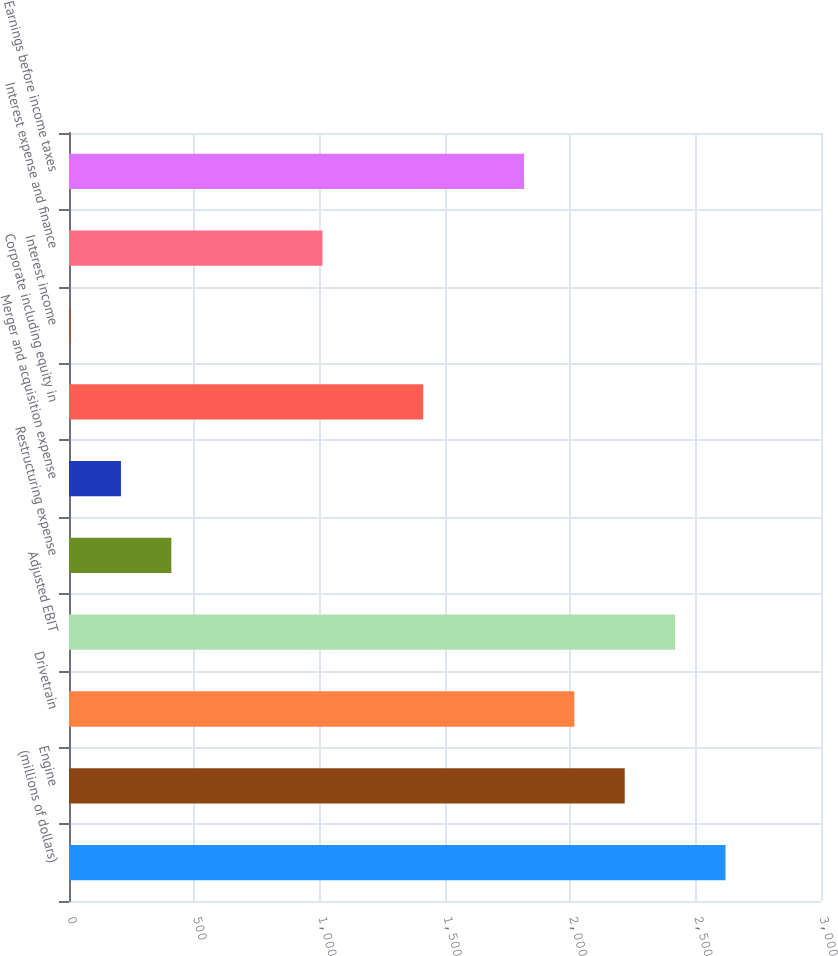<chart> <loc_0><loc_0><loc_500><loc_500><bar_chart><fcel>(millions of dollars)<fcel>Engine<fcel>Drivetrain<fcel>Adjusted EBIT<fcel>Restructuring expense<fcel>Merger and acquisition expense<fcel>Corporate including equity in<fcel>Interest income<fcel>Interest expense and finance<fcel>Earnings before income taxes<nl><fcel>2618.91<fcel>2216.97<fcel>2016<fcel>2417.94<fcel>408.24<fcel>207.27<fcel>1413.09<fcel>6.3<fcel>1011.15<fcel>1815.03<nl></chart> 